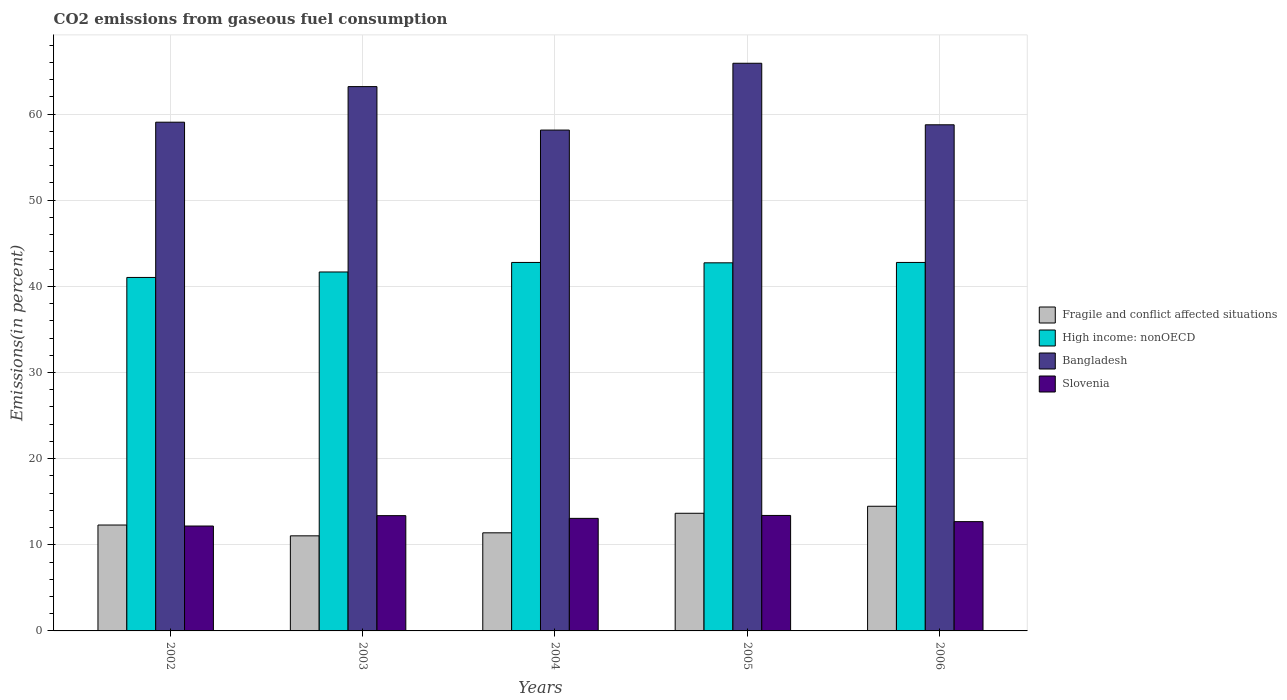How many groups of bars are there?
Offer a very short reply. 5. How many bars are there on the 1st tick from the right?
Provide a short and direct response. 4. In how many cases, is the number of bars for a given year not equal to the number of legend labels?
Offer a very short reply. 0. What is the total CO2 emitted in Bangladesh in 2004?
Keep it short and to the point. 58.14. Across all years, what is the maximum total CO2 emitted in High income: nonOECD?
Give a very brief answer. 42.77. Across all years, what is the minimum total CO2 emitted in Fragile and conflict affected situations?
Provide a short and direct response. 11.04. In which year was the total CO2 emitted in Fragile and conflict affected situations minimum?
Ensure brevity in your answer.  2003. What is the total total CO2 emitted in Slovenia in the graph?
Ensure brevity in your answer.  64.71. What is the difference between the total CO2 emitted in Bangladesh in 2003 and that in 2004?
Offer a very short reply. 5.05. What is the difference between the total CO2 emitted in Fragile and conflict affected situations in 2005 and the total CO2 emitted in Slovenia in 2003?
Your response must be concise. 0.28. What is the average total CO2 emitted in Slovenia per year?
Give a very brief answer. 12.94. In the year 2003, what is the difference between the total CO2 emitted in Slovenia and total CO2 emitted in Bangladesh?
Keep it short and to the point. -49.8. What is the ratio of the total CO2 emitted in High income: nonOECD in 2004 to that in 2006?
Make the answer very short. 1. What is the difference between the highest and the second highest total CO2 emitted in High income: nonOECD?
Offer a very short reply. 0. What is the difference between the highest and the lowest total CO2 emitted in Bangladesh?
Your answer should be compact. 7.76. In how many years, is the total CO2 emitted in Fragile and conflict affected situations greater than the average total CO2 emitted in Fragile and conflict affected situations taken over all years?
Make the answer very short. 2. What does the 4th bar from the left in 2003 represents?
Your answer should be compact. Slovenia. What does the 4th bar from the right in 2002 represents?
Provide a short and direct response. Fragile and conflict affected situations. How many bars are there?
Offer a very short reply. 20. Are all the bars in the graph horizontal?
Offer a terse response. No. How many years are there in the graph?
Provide a short and direct response. 5. Are the values on the major ticks of Y-axis written in scientific E-notation?
Offer a very short reply. No. Does the graph contain grids?
Your answer should be very brief. Yes. Where does the legend appear in the graph?
Ensure brevity in your answer.  Center right. How are the legend labels stacked?
Offer a very short reply. Vertical. What is the title of the graph?
Your response must be concise. CO2 emissions from gaseous fuel consumption. What is the label or title of the Y-axis?
Give a very brief answer. Emissions(in percent). What is the Emissions(in percent) in Fragile and conflict affected situations in 2002?
Ensure brevity in your answer.  12.29. What is the Emissions(in percent) of High income: nonOECD in 2002?
Provide a succinct answer. 41.03. What is the Emissions(in percent) of Bangladesh in 2002?
Keep it short and to the point. 59.05. What is the Emissions(in percent) in Slovenia in 2002?
Your answer should be compact. 12.18. What is the Emissions(in percent) of Fragile and conflict affected situations in 2003?
Your answer should be very brief. 11.04. What is the Emissions(in percent) in High income: nonOECD in 2003?
Your answer should be very brief. 41.66. What is the Emissions(in percent) of Bangladesh in 2003?
Keep it short and to the point. 63.18. What is the Emissions(in percent) of Slovenia in 2003?
Your answer should be very brief. 13.38. What is the Emissions(in percent) of Fragile and conflict affected situations in 2004?
Give a very brief answer. 11.39. What is the Emissions(in percent) in High income: nonOECD in 2004?
Offer a very short reply. 42.77. What is the Emissions(in percent) in Bangladesh in 2004?
Make the answer very short. 58.14. What is the Emissions(in percent) of Slovenia in 2004?
Your response must be concise. 13.06. What is the Emissions(in percent) in Fragile and conflict affected situations in 2005?
Provide a succinct answer. 13.66. What is the Emissions(in percent) of High income: nonOECD in 2005?
Give a very brief answer. 42.73. What is the Emissions(in percent) of Bangladesh in 2005?
Provide a short and direct response. 65.89. What is the Emissions(in percent) in Slovenia in 2005?
Make the answer very short. 13.4. What is the Emissions(in percent) of Fragile and conflict affected situations in 2006?
Your response must be concise. 14.47. What is the Emissions(in percent) of High income: nonOECD in 2006?
Make the answer very short. 42.77. What is the Emissions(in percent) in Bangladesh in 2006?
Provide a succinct answer. 58.75. What is the Emissions(in percent) in Slovenia in 2006?
Your answer should be compact. 12.69. Across all years, what is the maximum Emissions(in percent) of Fragile and conflict affected situations?
Offer a very short reply. 14.47. Across all years, what is the maximum Emissions(in percent) of High income: nonOECD?
Your answer should be very brief. 42.77. Across all years, what is the maximum Emissions(in percent) of Bangladesh?
Provide a short and direct response. 65.89. Across all years, what is the maximum Emissions(in percent) of Slovenia?
Give a very brief answer. 13.4. Across all years, what is the minimum Emissions(in percent) in Fragile and conflict affected situations?
Your response must be concise. 11.04. Across all years, what is the minimum Emissions(in percent) of High income: nonOECD?
Give a very brief answer. 41.03. Across all years, what is the minimum Emissions(in percent) in Bangladesh?
Your answer should be very brief. 58.14. Across all years, what is the minimum Emissions(in percent) of Slovenia?
Your answer should be very brief. 12.18. What is the total Emissions(in percent) in Fragile and conflict affected situations in the graph?
Offer a very short reply. 62.84. What is the total Emissions(in percent) of High income: nonOECD in the graph?
Offer a very short reply. 210.96. What is the total Emissions(in percent) in Bangladesh in the graph?
Make the answer very short. 305.01. What is the total Emissions(in percent) in Slovenia in the graph?
Offer a very short reply. 64.71. What is the difference between the Emissions(in percent) of Fragile and conflict affected situations in 2002 and that in 2003?
Offer a very short reply. 1.25. What is the difference between the Emissions(in percent) in High income: nonOECD in 2002 and that in 2003?
Provide a short and direct response. -0.63. What is the difference between the Emissions(in percent) in Bangladesh in 2002 and that in 2003?
Offer a very short reply. -4.13. What is the difference between the Emissions(in percent) of Slovenia in 2002 and that in 2003?
Your answer should be compact. -1.2. What is the difference between the Emissions(in percent) of Fragile and conflict affected situations in 2002 and that in 2004?
Your response must be concise. 0.9. What is the difference between the Emissions(in percent) of High income: nonOECD in 2002 and that in 2004?
Keep it short and to the point. -1.74. What is the difference between the Emissions(in percent) in Bangladesh in 2002 and that in 2004?
Your answer should be very brief. 0.91. What is the difference between the Emissions(in percent) of Slovenia in 2002 and that in 2004?
Your answer should be compact. -0.89. What is the difference between the Emissions(in percent) of Fragile and conflict affected situations in 2002 and that in 2005?
Your response must be concise. -1.36. What is the difference between the Emissions(in percent) of High income: nonOECD in 2002 and that in 2005?
Offer a terse response. -1.7. What is the difference between the Emissions(in percent) of Bangladesh in 2002 and that in 2005?
Provide a succinct answer. -6.84. What is the difference between the Emissions(in percent) of Slovenia in 2002 and that in 2005?
Provide a succinct answer. -1.23. What is the difference between the Emissions(in percent) of Fragile and conflict affected situations in 2002 and that in 2006?
Your answer should be very brief. -2.18. What is the difference between the Emissions(in percent) in High income: nonOECD in 2002 and that in 2006?
Offer a very short reply. -1.74. What is the difference between the Emissions(in percent) in Bangladesh in 2002 and that in 2006?
Provide a short and direct response. 0.3. What is the difference between the Emissions(in percent) in Slovenia in 2002 and that in 2006?
Make the answer very short. -0.51. What is the difference between the Emissions(in percent) of Fragile and conflict affected situations in 2003 and that in 2004?
Your answer should be compact. -0.35. What is the difference between the Emissions(in percent) of High income: nonOECD in 2003 and that in 2004?
Your answer should be compact. -1.11. What is the difference between the Emissions(in percent) in Bangladesh in 2003 and that in 2004?
Provide a short and direct response. 5.05. What is the difference between the Emissions(in percent) of Slovenia in 2003 and that in 2004?
Your response must be concise. 0.32. What is the difference between the Emissions(in percent) of Fragile and conflict affected situations in 2003 and that in 2005?
Ensure brevity in your answer.  -2.62. What is the difference between the Emissions(in percent) in High income: nonOECD in 2003 and that in 2005?
Make the answer very short. -1.06. What is the difference between the Emissions(in percent) in Bangladesh in 2003 and that in 2005?
Provide a short and direct response. -2.71. What is the difference between the Emissions(in percent) of Slovenia in 2003 and that in 2005?
Your answer should be very brief. -0.02. What is the difference between the Emissions(in percent) of Fragile and conflict affected situations in 2003 and that in 2006?
Offer a very short reply. -3.43. What is the difference between the Emissions(in percent) of High income: nonOECD in 2003 and that in 2006?
Your answer should be very brief. -1.11. What is the difference between the Emissions(in percent) in Bangladesh in 2003 and that in 2006?
Give a very brief answer. 4.43. What is the difference between the Emissions(in percent) of Slovenia in 2003 and that in 2006?
Make the answer very short. 0.69. What is the difference between the Emissions(in percent) in Fragile and conflict affected situations in 2004 and that in 2005?
Your response must be concise. -2.27. What is the difference between the Emissions(in percent) of High income: nonOECD in 2004 and that in 2005?
Provide a short and direct response. 0.04. What is the difference between the Emissions(in percent) of Bangladesh in 2004 and that in 2005?
Give a very brief answer. -7.76. What is the difference between the Emissions(in percent) of Slovenia in 2004 and that in 2005?
Give a very brief answer. -0.34. What is the difference between the Emissions(in percent) in Fragile and conflict affected situations in 2004 and that in 2006?
Your response must be concise. -3.08. What is the difference between the Emissions(in percent) in High income: nonOECD in 2004 and that in 2006?
Keep it short and to the point. 0. What is the difference between the Emissions(in percent) in Bangladesh in 2004 and that in 2006?
Give a very brief answer. -0.61. What is the difference between the Emissions(in percent) in Slovenia in 2004 and that in 2006?
Offer a terse response. 0.38. What is the difference between the Emissions(in percent) in Fragile and conflict affected situations in 2005 and that in 2006?
Your answer should be very brief. -0.81. What is the difference between the Emissions(in percent) of High income: nonOECD in 2005 and that in 2006?
Make the answer very short. -0.04. What is the difference between the Emissions(in percent) of Bangladesh in 2005 and that in 2006?
Make the answer very short. 7.14. What is the difference between the Emissions(in percent) of Slovenia in 2005 and that in 2006?
Your response must be concise. 0.72. What is the difference between the Emissions(in percent) of Fragile and conflict affected situations in 2002 and the Emissions(in percent) of High income: nonOECD in 2003?
Provide a short and direct response. -29.37. What is the difference between the Emissions(in percent) in Fragile and conflict affected situations in 2002 and the Emissions(in percent) in Bangladesh in 2003?
Make the answer very short. -50.89. What is the difference between the Emissions(in percent) of Fragile and conflict affected situations in 2002 and the Emissions(in percent) of Slovenia in 2003?
Keep it short and to the point. -1.09. What is the difference between the Emissions(in percent) in High income: nonOECD in 2002 and the Emissions(in percent) in Bangladesh in 2003?
Ensure brevity in your answer.  -22.15. What is the difference between the Emissions(in percent) of High income: nonOECD in 2002 and the Emissions(in percent) of Slovenia in 2003?
Provide a short and direct response. 27.65. What is the difference between the Emissions(in percent) in Bangladesh in 2002 and the Emissions(in percent) in Slovenia in 2003?
Give a very brief answer. 45.67. What is the difference between the Emissions(in percent) of Fragile and conflict affected situations in 2002 and the Emissions(in percent) of High income: nonOECD in 2004?
Make the answer very short. -30.48. What is the difference between the Emissions(in percent) of Fragile and conflict affected situations in 2002 and the Emissions(in percent) of Bangladesh in 2004?
Make the answer very short. -45.84. What is the difference between the Emissions(in percent) in Fragile and conflict affected situations in 2002 and the Emissions(in percent) in Slovenia in 2004?
Keep it short and to the point. -0.77. What is the difference between the Emissions(in percent) of High income: nonOECD in 2002 and the Emissions(in percent) of Bangladesh in 2004?
Ensure brevity in your answer.  -17.11. What is the difference between the Emissions(in percent) of High income: nonOECD in 2002 and the Emissions(in percent) of Slovenia in 2004?
Keep it short and to the point. 27.97. What is the difference between the Emissions(in percent) of Bangladesh in 2002 and the Emissions(in percent) of Slovenia in 2004?
Keep it short and to the point. 45.99. What is the difference between the Emissions(in percent) of Fragile and conflict affected situations in 2002 and the Emissions(in percent) of High income: nonOECD in 2005?
Offer a very short reply. -30.43. What is the difference between the Emissions(in percent) in Fragile and conflict affected situations in 2002 and the Emissions(in percent) in Bangladesh in 2005?
Offer a very short reply. -53.6. What is the difference between the Emissions(in percent) of Fragile and conflict affected situations in 2002 and the Emissions(in percent) of Slovenia in 2005?
Make the answer very short. -1.11. What is the difference between the Emissions(in percent) of High income: nonOECD in 2002 and the Emissions(in percent) of Bangladesh in 2005?
Provide a succinct answer. -24.86. What is the difference between the Emissions(in percent) of High income: nonOECD in 2002 and the Emissions(in percent) of Slovenia in 2005?
Offer a very short reply. 27.63. What is the difference between the Emissions(in percent) of Bangladesh in 2002 and the Emissions(in percent) of Slovenia in 2005?
Your response must be concise. 45.65. What is the difference between the Emissions(in percent) in Fragile and conflict affected situations in 2002 and the Emissions(in percent) in High income: nonOECD in 2006?
Your answer should be very brief. -30.48. What is the difference between the Emissions(in percent) of Fragile and conflict affected situations in 2002 and the Emissions(in percent) of Bangladesh in 2006?
Offer a terse response. -46.46. What is the difference between the Emissions(in percent) of Fragile and conflict affected situations in 2002 and the Emissions(in percent) of Slovenia in 2006?
Make the answer very short. -0.39. What is the difference between the Emissions(in percent) of High income: nonOECD in 2002 and the Emissions(in percent) of Bangladesh in 2006?
Make the answer very short. -17.72. What is the difference between the Emissions(in percent) of High income: nonOECD in 2002 and the Emissions(in percent) of Slovenia in 2006?
Offer a very short reply. 28.34. What is the difference between the Emissions(in percent) of Bangladesh in 2002 and the Emissions(in percent) of Slovenia in 2006?
Make the answer very short. 46.37. What is the difference between the Emissions(in percent) in Fragile and conflict affected situations in 2003 and the Emissions(in percent) in High income: nonOECD in 2004?
Give a very brief answer. -31.73. What is the difference between the Emissions(in percent) in Fragile and conflict affected situations in 2003 and the Emissions(in percent) in Bangladesh in 2004?
Offer a terse response. -47.1. What is the difference between the Emissions(in percent) of Fragile and conflict affected situations in 2003 and the Emissions(in percent) of Slovenia in 2004?
Offer a terse response. -2.03. What is the difference between the Emissions(in percent) of High income: nonOECD in 2003 and the Emissions(in percent) of Bangladesh in 2004?
Provide a succinct answer. -16.47. What is the difference between the Emissions(in percent) of High income: nonOECD in 2003 and the Emissions(in percent) of Slovenia in 2004?
Make the answer very short. 28.6. What is the difference between the Emissions(in percent) in Bangladesh in 2003 and the Emissions(in percent) in Slovenia in 2004?
Make the answer very short. 50.12. What is the difference between the Emissions(in percent) of Fragile and conflict affected situations in 2003 and the Emissions(in percent) of High income: nonOECD in 2005?
Your response must be concise. -31.69. What is the difference between the Emissions(in percent) in Fragile and conflict affected situations in 2003 and the Emissions(in percent) in Bangladesh in 2005?
Your answer should be very brief. -54.85. What is the difference between the Emissions(in percent) in Fragile and conflict affected situations in 2003 and the Emissions(in percent) in Slovenia in 2005?
Your response must be concise. -2.37. What is the difference between the Emissions(in percent) in High income: nonOECD in 2003 and the Emissions(in percent) in Bangladesh in 2005?
Provide a succinct answer. -24.23. What is the difference between the Emissions(in percent) of High income: nonOECD in 2003 and the Emissions(in percent) of Slovenia in 2005?
Your answer should be compact. 28.26. What is the difference between the Emissions(in percent) in Bangladesh in 2003 and the Emissions(in percent) in Slovenia in 2005?
Provide a short and direct response. 49.78. What is the difference between the Emissions(in percent) in Fragile and conflict affected situations in 2003 and the Emissions(in percent) in High income: nonOECD in 2006?
Make the answer very short. -31.73. What is the difference between the Emissions(in percent) in Fragile and conflict affected situations in 2003 and the Emissions(in percent) in Bangladesh in 2006?
Offer a terse response. -47.71. What is the difference between the Emissions(in percent) of Fragile and conflict affected situations in 2003 and the Emissions(in percent) of Slovenia in 2006?
Keep it short and to the point. -1.65. What is the difference between the Emissions(in percent) in High income: nonOECD in 2003 and the Emissions(in percent) in Bangladesh in 2006?
Give a very brief answer. -17.09. What is the difference between the Emissions(in percent) in High income: nonOECD in 2003 and the Emissions(in percent) in Slovenia in 2006?
Your answer should be compact. 28.98. What is the difference between the Emissions(in percent) of Bangladesh in 2003 and the Emissions(in percent) of Slovenia in 2006?
Provide a succinct answer. 50.5. What is the difference between the Emissions(in percent) in Fragile and conflict affected situations in 2004 and the Emissions(in percent) in High income: nonOECD in 2005?
Make the answer very short. -31.34. What is the difference between the Emissions(in percent) of Fragile and conflict affected situations in 2004 and the Emissions(in percent) of Bangladesh in 2005?
Make the answer very short. -54.5. What is the difference between the Emissions(in percent) in Fragile and conflict affected situations in 2004 and the Emissions(in percent) in Slovenia in 2005?
Ensure brevity in your answer.  -2.02. What is the difference between the Emissions(in percent) in High income: nonOECD in 2004 and the Emissions(in percent) in Bangladesh in 2005?
Your answer should be very brief. -23.12. What is the difference between the Emissions(in percent) in High income: nonOECD in 2004 and the Emissions(in percent) in Slovenia in 2005?
Your answer should be compact. 29.37. What is the difference between the Emissions(in percent) in Bangladesh in 2004 and the Emissions(in percent) in Slovenia in 2005?
Your answer should be compact. 44.73. What is the difference between the Emissions(in percent) of Fragile and conflict affected situations in 2004 and the Emissions(in percent) of High income: nonOECD in 2006?
Provide a short and direct response. -31.38. What is the difference between the Emissions(in percent) in Fragile and conflict affected situations in 2004 and the Emissions(in percent) in Bangladesh in 2006?
Ensure brevity in your answer.  -47.36. What is the difference between the Emissions(in percent) of Fragile and conflict affected situations in 2004 and the Emissions(in percent) of Slovenia in 2006?
Provide a succinct answer. -1.3. What is the difference between the Emissions(in percent) in High income: nonOECD in 2004 and the Emissions(in percent) in Bangladesh in 2006?
Make the answer very short. -15.98. What is the difference between the Emissions(in percent) in High income: nonOECD in 2004 and the Emissions(in percent) in Slovenia in 2006?
Keep it short and to the point. 30.09. What is the difference between the Emissions(in percent) in Bangladesh in 2004 and the Emissions(in percent) in Slovenia in 2006?
Provide a succinct answer. 45.45. What is the difference between the Emissions(in percent) of Fragile and conflict affected situations in 2005 and the Emissions(in percent) of High income: nonOECD in 2006?
Offer a terse response. -29.11. What is the difference between the Emissions(in percent) of Fragile and conflict affected situations in 2005 and the Emissions(in percent) of Bangladesh in 2006?
Your answer should be compact. -45.09. What is the difference between the Emissions(in percent) of Fragile and conflict affected situations in 2005 and the Emissions(in percent) of Slovenia in 2006?
Your answer should be very brief. 0.97. What is the difference between the Emissions(in percent) in High income: nonOECD in 2005 and the Emissions(in percent) in Bangladesh in 2006?
Provide a short and direct response. -16.02. What is the difference between the Emissions(in percent) of High income: nonOECD in 2005 and the Emissions(in percent) of Slovenia in 2006?
Your answer should be compact. 30.04. What is the difference between the Emissions(in percent) of Bangladesh in 2005 and the Emissions(in percent) of Slovenia in 2006?
Make the answer very short. 53.21. What is the average Emissions(in percent) in Fragile and conflict affected situations per year?
Keep it short and to the point. 12.57. What is the average Emissions(in percent) in High income: nonOECD per year?
Your response must be concise. 42.19. What is the average Emissions(in percent) in Bangladesh per year?
Your response must be concise. 61. What is the average Emissions(in percent) in Slovenia per year?
Provide a short and direct response. 12.94. In the year 2002, what is the difference between the Emissions(in percent) in Fragile and conflict affected situations and Emissions(in percent) in High income: nonOECD?
Your answer should be very brief. -28.74. In the year 2002, what is the difference between the Emissions(in percent) of Fragile and conflict affected situations and Emissions(in percent) of Bangladesh?
Ensure brevity in your answer.  -46.76. In the year 2002, what is the difference between the Emissions(in percent) in Fragile and conflict affected situations and Emissions(in percent) in Slovenia?
Offer a very short reply. 0.12. In the year 2002, what is the difference between the Emissions(in percent) in High income: nonOECD and Emissions(in percent) in Bangladesh?
Make the answer very short. -18.02. In the year 2002, what is the difference between the Emissions(in percent) of High income: nonOECD and Emissions(in percent) of Slovenia?
Provide a short and direct response. 28.85. In the year 2002, what is the difference between the Emissions(in percent) of Bangladesh and Emissions(in percent) of Slovenia?
Give a very brief answer. 46.88. In the year 2003, what is the difference between the Emissions(in percent) in Fragile and conflict affected situations and Emissions(in percent) in High income: nonOECD?
Offer a terse response. -30.63. In the year 2003, what is the difference between the Emissions(in percent) in Fragile and conflict affected situations and Emissions(in percent) in Bangladesh?
Your response must be concise. -52.14. In the year 2003, what is the difference between the Emissions(in percent) in Fragile and conflict affected situations and Emissions(in percent) in Slovenia?
Ensure brevity in your answer.  -2.34. In the year 2003, what is the difference between the Emissions(in percent) in High income: nonOECD and Emissions(in percent) in Bangladesh?
Your answer should be very brief. -21.52. In the year 2003, what is the difference between the Emissions(in percent) of High income: nonOECD and Emissions(in percent) of Slovenia?
Provide a short and direct response. 28.28. In the year 2003, what is the difference between the Emissions(in percent) of Bangladesh and Emissions(in percent) of Slovenia?
Your answer should be compact. 49.8. In the year 2004, what is the difference between the Emissions(in percent) in Fragile and conflict affected situations and Emissions(in percent) in High income: nonOECD?
Provide a short and direct response. -31.38. In the year 2004, what is the difference between the Emissions(in percent) in Fragile and conflict affected situations and Emissions(in percent) in Bangladesh?
Make the answer very short. -46.75. In the year 2004, what is the difference between the Emissions(in percent) of Fragile and conflict affected situations and Emissions(in percent) of Slovenia?
Your response must be concise. -1.68. In the year 2004, what is the difference between the Emissions(in percent) in High income: nonOECD and Emissions(in percent) in Bangladesh?
Keep it short and to the point. -15.37. In the year 2004, what is the difference between the Emissions(in percent) in High income: nonOECD and Emissions(in percent) in Slovenia?
Provide a short and direct response. 29.71. In the year 2004, what is the difference between the Emissions(in percent) of Bangladesh and Emissions(in percent) of Slovenia?
Provide a succinct answer. 45.07. In the year 2005, what is the difference between the Emissions(in percent) of Fragile and conflict affected situations and Emissions(in percent) of High income: nonOECD?
Your response must be concise. -29.07. In the year 2005, what is the difference between the Emissions(in percent) in Fragile and conflict affected situations and Emissions(in percent) in Bangladesh?
Your answer should be compact. -52.24. In the year 2005, what is the difference between the Emissions(in percent) of Fragile and conflict affected situations and Emissions(in percent) of Slovenia?
Give a very brief answer. 0.25. In the year 2005, what is the difference between the Emissions(in percent) in High income: nonOECD and Emissions(in percent) in Bangladesh?
Ensure brevity in your answer.  -23.16. In the year 2005, what is the difference between the Emissions(in percent) in High income: nonOECD and Emissions(in percent) in Slovenia?
Give a very brief answer. 29.32. In the year 2005, what is the difference between the Emissions(in percent) of Bangladesh and Emissions(in percent) of Slovenia?
Keep it short and to the point. 52.49. In the year 2006, what is the difference between the Emissions(in percent) of Fragile and conflict affected situations and Emissions(in percent) of High income: nonOECD?
Make the answer very short. -28.3. In the year 2006, what is the difference between the Emissions(in percent) of Fragile and conflict affected situations and Emissions(in percent) of Bangladesh?
Offer a terse response. -44.28. In the year 2006, what is the difference between the Emissions(in percent) in Fragile and conflict affected situations and Emissions(in percent) in Slovenia?
Offer a very short reply. 1.78. In the year 2006, what is the difference between the Emissions(in percent) in High income: nonOECD and Emissions(in percent) in Bangladesh?
Give a very brief answer. -15.98. In the year 2006, what is the difference between the Emissions(in percent) of High income: nonOECD and Emissions(in percent) of Slovenia?
Offer a very short reply. 30.08. In the year 2006, what is the difference between the Emissions(in percent) in Bangladesh and Emissions(in percent) in Slovenia?
Offer a very short reply. 46.06. What is the ratio of the Emissions(in percent) of Fragile and conflict affected situations in 2002 to that in 2003?
Keep it short and to the point. 1.11. What is the ratio of the Emissions(in percent) of Bangladesh in 2002 to that in 2003?
Provide a succinct answer. 0.93. What is the ratio of the Emissions(in percent) in Slovenia in 2002 to that in 2003?
Make the answer very short. 0.91. What is the ratio of the Emissions(in percent) of Fragile and conflict affected situations in 2002 to that in 2004?
Make the answer very short. 1.08. What is the ratio of the Emissions(in percent) in High income: nonOECD in 2002 to that in 2004?
Your answer should be very brief. 0.96. What is the ratio of the Emissions(in percent) of Bangladesh in 2002 to that in 2004?
Make the answer very short. 1.02. What is the ratio of the Emissions(in percent) of Slovenia in 2002 to that in 2004?
Provide a succinct answer. 0.93. What is the ratio of the Emissions(in percent) of Fragile and conflict affected situations in 2002 to that in 2005?
Provide a short and direct response. 0.9. What is the ratio of the Emissions(in percent) of High income: nonOECD in 2002 to that in 2005?
Your answer should be compact. 0.96. What is the ratio of the Emissions(in percent) in Bangladesh in 2002 to that in 2005?
Your answer should be very brief. 0.9. What is the ratio of the Emissions(in percent) in Slovenia in 2002 to that in 2005?
Provide a short and direct response. 0.91. What is the ratio of the Emissions(in percent) of Fragile and conflict affected situations in 2002 to that in 2006?
Offer a terse response. 0.85. What is the ratio of the Emissions(in percent) in High income: nonOECD in 2002 to that in 2006?
Your response must be concise. 0.96. What is the ratio of the Emissions(in percent) of Slovenia in 2002 to that in 2006?
Provide a short and direct response. 0.96. What is the ratio of the Emissions(in percent) in Fragile and conflict affected situations in 2003 to that in 2004?
Your answer should be very brief. 0.97. What is the ratio of the Emissions(in percent) in High income: nonOECD in 2003 to that in 2004?
Your answer should be very brief. 0.97. What is the ratio of the Emissions(in percent) of Bangladesh in 2003 to that in 2004?
Your answer should be compact. 1.09. What is the ratio of the Emissions(in percent) in Slovenia in 2003 to that in 2004?
Offer a very short reply. 1.02. What is the ratio of the Emissions(in percent) of Fragile and conflict affected situations in 2003 to that in 2005?
Ensure brevity in your answer.  0.81. What is the ratio of the Emissions(in percent) of High income: nonOECD in 2003 to that in 2005?
Provide a succinct answer. 0.98. What is the ratio of the Emissions(in percent) of Bangladesh in 2003 to that in 2005?
Your response must be concise. 0.96. What is the ratio of the Emissions(in percent) of Fragile and conflict affected situations in 2003 to that in 2006?
Offer a very short reply. 0.76. What is the ratio of the Emissions(in percent) of High income: nonOECD in 2003 to that in 2006?
Provide a succinct answer. 0.97. What is the ratio of the Emissions(in percent) in Bangladesh in 2003 to that in 2006?
Offer a terse response. 1.08. What is the ratio of the Emissions(in percent) in Slovenia in 2003 to that in 2006?
Ensure brevity in your answer.  1.05. What is the ratio of the Emissions(in percent) of Fragile and conflict affected situations in 2004 to that in 2005?
Provide a succinct answer. 0.83. What is the ratio of the Emissions(in percent) in High income: nonOECD in 2004 to that in 2005?
Offer a very short reply. 1. What is the ratio of the Emissions(in percent) of Bangladesh in 2004 to that in 2005?
Offer a terse response. 0.88. What is the ratio of the Emissions(in percent) in Slovenia in 2004 to that in 2005?
Give a very brief answer. 0.97. What is the ratio of the Emissions(in percent) of Fragile and conflict affected situations in 2004 to that in 2006?
Your answer should be very brief. 0.79. What is the ratio of the Emissions(in percent) of High income: nonOECD in 2004 to that in 2006?
Offer a very short reply. 1. What is the ratio of the Emissions(in percent) in Bangladesh in 2004 to that in 2006?
Your answer should be very brief. 0.99. What is the ratio of the Emissions(in percent) of Slovenia in 2004 to that in 2006?
Provide a short and direct response. 1.03. What is the ratio of the Emissions(in percent) of Fragile and conflict affected situations in 2005 to that in 2006?
Give a very brief answer. 0.94. What is the ratio of the Emissions(in percent) in High income: nonOECD in 2005 to that in 2006?
Provide a succinct answer. 1. What is the ratio of the Emissions(in percent) in Bangladesh in 2005 to that in 2006?
Your answer should be compact. 1.12. What is the ratio of the Emissions(in percent) in Slovenia in 2005 to that in 2006?
Provide a short and direct response. 1.06. What is the difference between the highest and the second highest Emissions(in percent) of Fragile and conflict affected situations?
Provide a succinct answer. 0.81. What is the difference between the highest and the second highest Emissions(in percent) in High income: nonOECD?
Offer a terse response. 0. What is the difference between the highest and the second highest Emissions(in percent) of Bangladesh?
Provide a succinct answer. 2.71. What is the difference between the highest and the second highest Emissions(in percent) of Slovenia?
Your answer should be very brief. 0.02. What is the difference between the highest and the lowest Emissions(in percent) of Fragile and conflict affected situations?
Your answer should be compact. 3.43. What is the difference between the highest and the lowest Emissions(in percent) of High income: nonOECD?
Give a very brief answer. 1.74. What is the difference between the highest and the lowest Emissions(in percent) in Bangladesh?
Your answer should be compact. 7.76. What is the difference between the highest and the lowest Emissions(in percent) in Slovenia?
Your answer should be very brief. 1.23. 